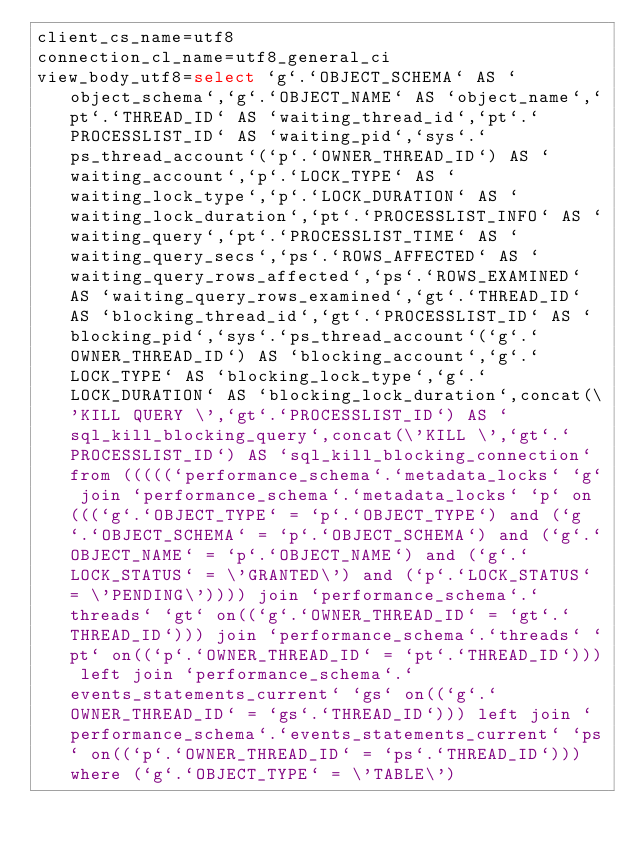<code> <loc_0><loc_0><loc_500><loc_500><_VisualBasic_>client_cs_name=utf8
connection_cl_name=utf8_general_ci
view_body_utf8=select `g`.`OBJECT_SCHEMA` AS `object_schema`,`g`.`OBJECT_NAME` AS `object_name`,`pt`.`THREAD_ID` AS `waiting_thread_id`,`pt`.`PROCESSLIST_ID` AS `waiting_pid`,`sys`.`ps_thread_account`(`p`.`OWNER_THREAD_ID`) AS `waiting_account`,`p`.`LOCK_TYPE` AS `waiting_lock_type`,`p`.`LOCK_DURATION` AS `waiting_lock_duration`,`pt`.`PROCESSLIST_INFO` AS `waiting_query`,`pt`.`PROCESSLIST_TIME` AS `waiting_query_secs`,`ps`.`ROWS_AFFECTED` AS `waiting_query_rows_affected`,`ps`.`ROWS_EXAMINED` AS `waiting_query_rows_examined`,`gt`.`THREAD_ID` AS `blocking_thread_id`,`gt`.`PROCESSLIST_ID` AS `blocking_pid`,`sys`.`ps_thread_account`(`g`.`OWNER_THREAD_ID`) AS `blocking_account`,`g`.`LOCK_TYPE` AS `blocking_lock_type`,`g`.`LOCK_DURATION` AS `blocking_lock_duration`,concat(\'KILL QUERY \',`gt`.`PROCESSLIST_ID`) AS `sql_kill_blocking_query`,concat(\'KILL \',`gt`.`PROCESSLIST_ID`) AS `sql_kill_blocking_connection` from (((((`performance_schema`.`metadata_locks` `g` join `performance_schema`.`metadata_locks` `p` on(((`g`.`OBJECT_TYPE` = `p`.`OBJECT_TYPE`) and (`g`.`OBJECT_SCHEMA` = `p`.`OBJECT_SCHEMA`) and (`g`.`OBJECT_NAME` = `p`.`OBJECT_NAME`) and (`g`.`LOCK_STATUS` = \'GRANTED\') and (`p`.`LOCK_STATUS` = \'PENDING\')))) join `performance_schema`.`threads` `gt` on((`g`.`OWNER_THREAD_ID` = `gt`.`THREAD_ID`))) join `performance_schema`.`threads` `pt` on((`p`.`OWNER_THREAD_ID` = `pt`.`THREAD_ID`))) left join `performance_schema`.`events_statements_current` `gs` on((`g`.`OWNER_THREAD_ID` = `gs`.`THREAD_ID`))) left join `performance_schema`.`events_statements_current` `ps` on((`p`.`OWNER_THREAD_ID` = `ps`.`THREAD_ID`))) where (`g`.`OBJECT_TYPE` = \'TABLE\')
</code> 